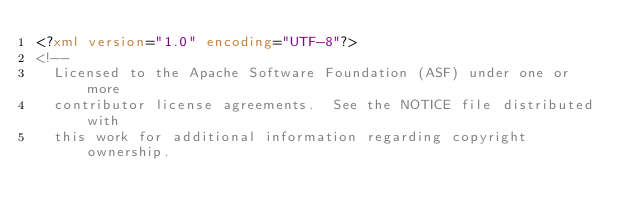<code> <loc_0><loc_0><loc_500><loc_500><_XML_><?xml version="1.0" encoding="UTF-8"?>
<!--
  Licensed to the Apache Software Foundation (ASF) under one or more
  contributor license agreements.  See the NOTICE file distributed with
  this work for additional information regarding copyright ownership.</code> 